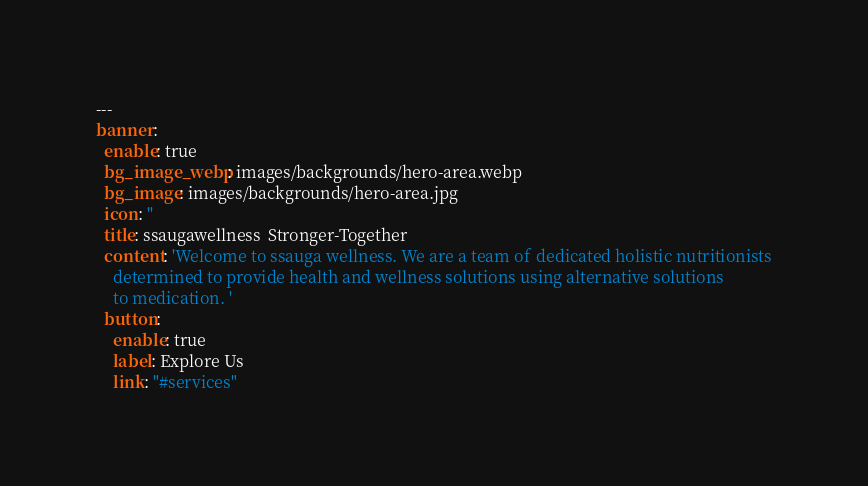Convert code to text. <code><loc_0><loc_0><loc_500><loc_500><_YAML_>---
banner:
  enable: true
  bg_image_webp: images/backgrounds/hero-area.webp
  bg_image: images/backgrounds/hero-area.jpg
  icon: ''
  title: ssaugawellness  Stronger-Together
  content: 'Welcome to ssauga wellness. We are a team of dedicated holistic nutritionists
    determined to provide health and wellness solutions using alternative solutions
    to medication. '
  button:
    enable: true
    label: Explore Us
    link: "#services"
</code> 